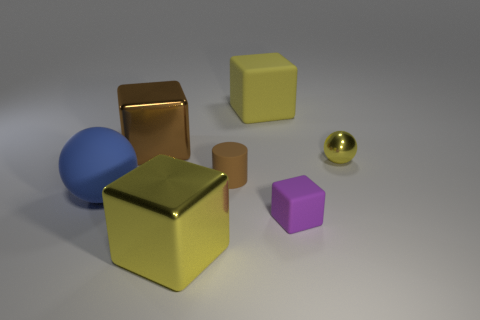How are the shadows in the image indicating the light source? The shadows cast by the objects are falling toward the bottom right of the image, which suggests the light source is coming from the top left. The soft edges of the shadows also indicate that the light source is not extremely close to the objects. 